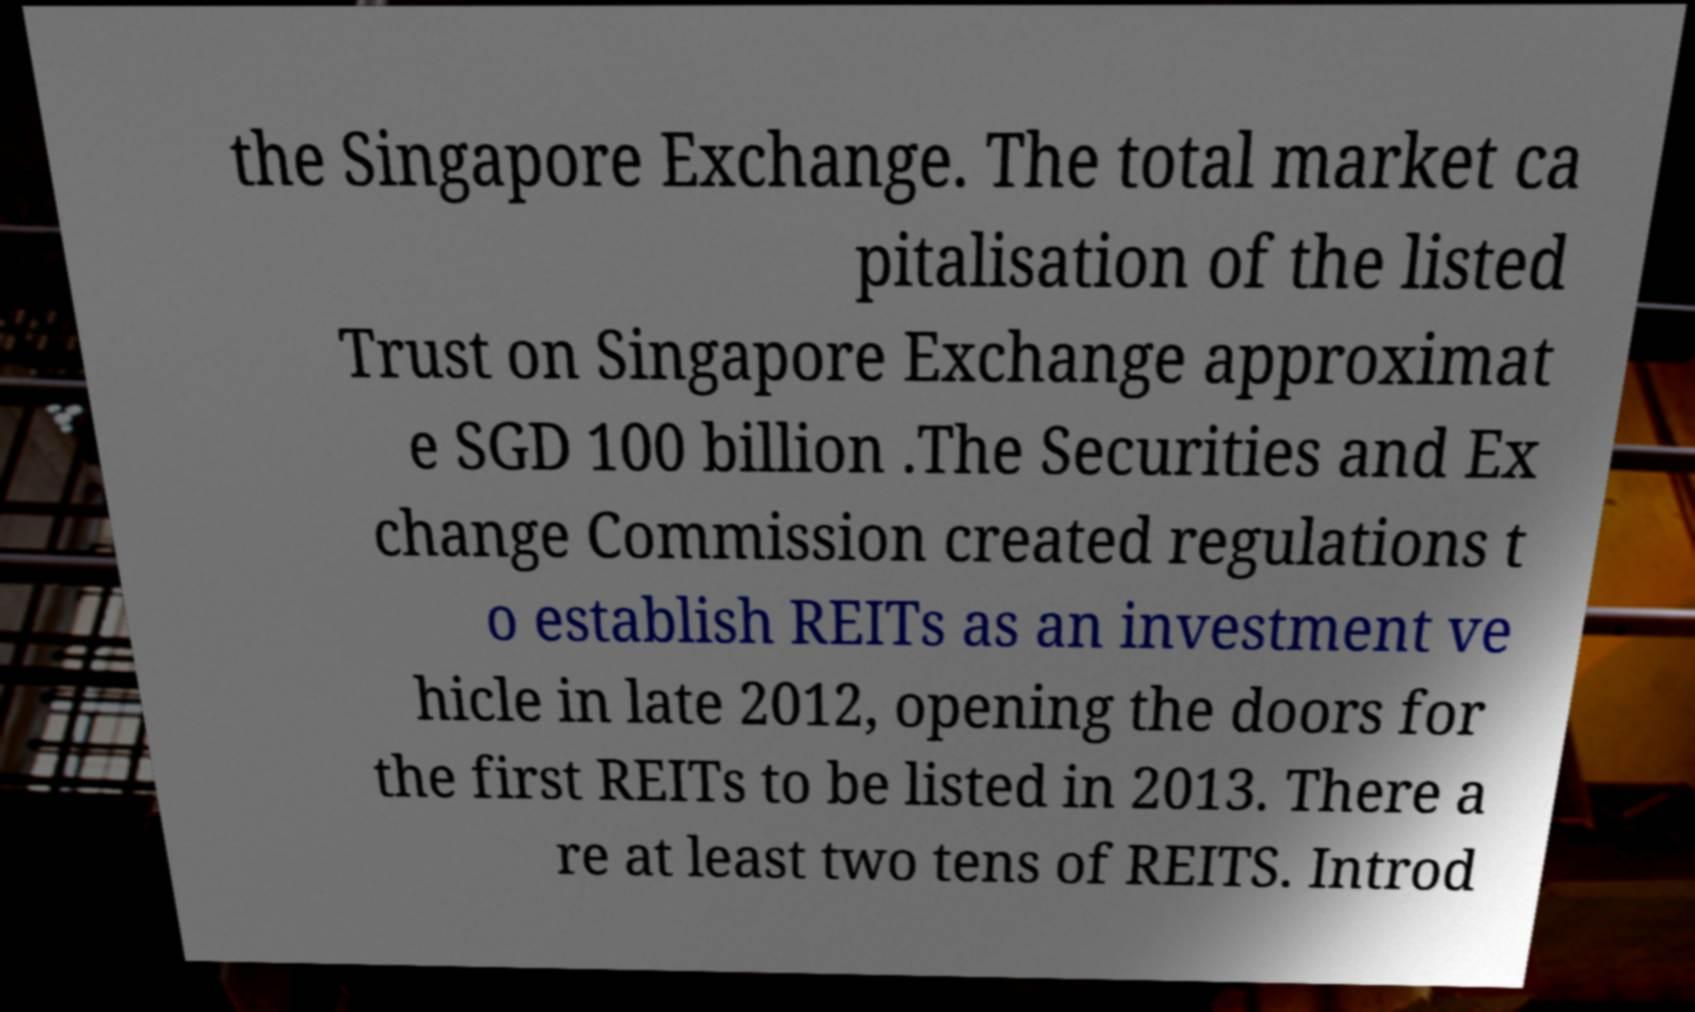Please read and relay the text visible in this image. What does it say? the Singapore Exchange. The total market ca pitalisation of the listed Trust on Singapore Exchange approximat e SGD 100 billion .The Securities and Ex change Commission created regulations t o establish REITs as an investment ve hicle in late 2012, opening the doors for the first REITs to be listed in 2013. There a re at least two tens of REITS. Introd 